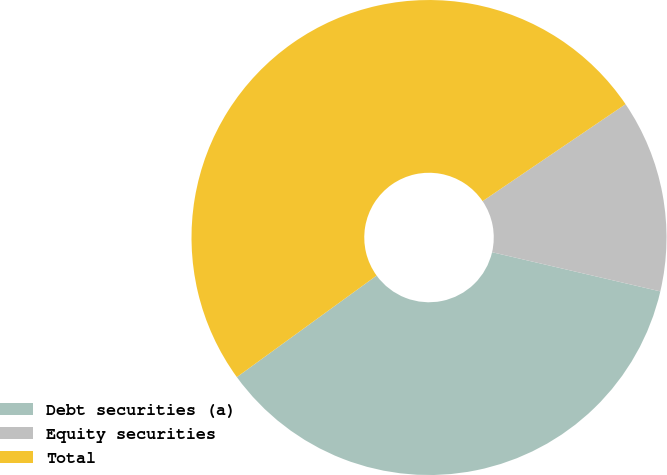Convert chart to OTSL. <chart><loc_0><loc_0><loc_500><loc_500><pie_chart><fcel>Debt securities (a)<fcel>Equity securities<fcel>Total<nl><fcel>36.36%<fcel>13.13%<fcel>50.51%<nl></chart> 